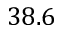<formula> <loc_0><loc_0><loc_500><loc_500>3 8 . 6</formula> 